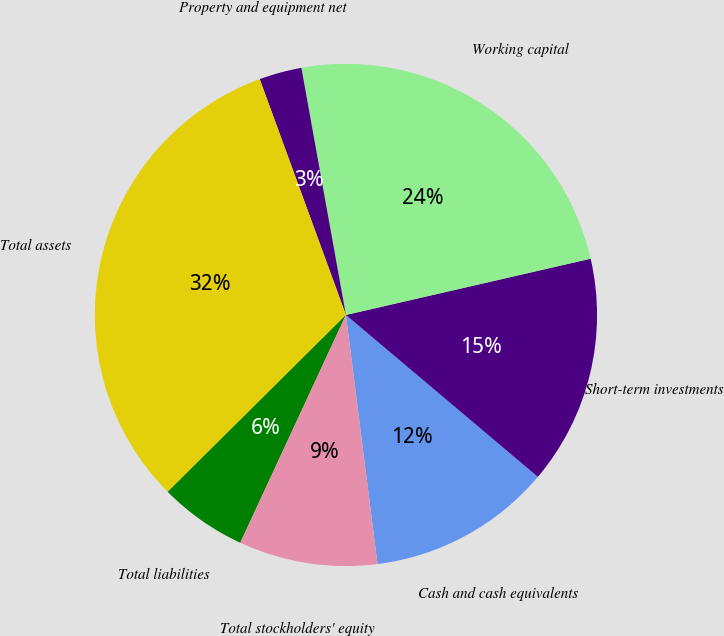Convert chart to OTSL. <chart><loc_0><loc_0><loc_500><loc_500><pie_chart><fcel>Cash and cash equivalents<fcel>Short-term investments<fcel>Working capital<fcel>Property and equipment net<fcel>Total assets<fcel>Total liabilities<fcel>Total stockholders' equity<nl><fcel>11.84%<fcel>14.75%<fcel>24.24%<fcel>2.74%<fcel>31.86%<fcel>5.65%<fcel>8.92%<nl></chart> 